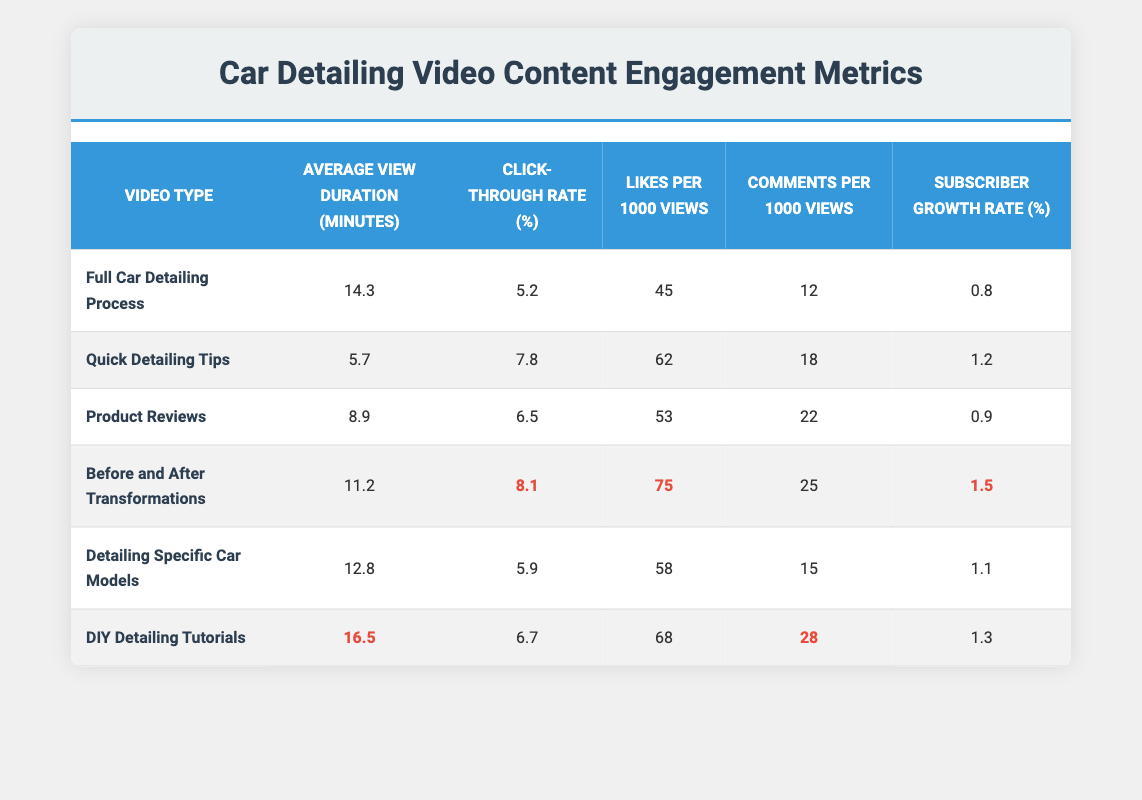What is the Average View Duration for "Full Car Detailing Process"? The Average View Duration for "Full Car Detailing Process" is listed in the table. It shows 14.3 minutes.
Answer: 14.3 minutes Which video type has the highest Click-Through Rate? The Click-Through Rate values are compared across all video types in the table. "Before and After Transformations" has the highest Click-Through Rate at 8.1%.
Answer: 8.1% How many Likes per 1000 Views does "DIY Detailing Tutorials" have? Referring directly to the table, "DIY Detailing Tutorials" shows 68 Likes per 1000 Views.
Answer: 68 Likes per 1000 Views What is the difference in Subscriber Growth Rate between "Before and After Transformations" and "Product Reviews"? From the table, "Before and After Transformations" has a Subscriber Growth Rate of 1.5% and "Product Reviews" has 0.9%. The difference is calculated as 1.5 - 0.9 = 0.6%.
Answer: 0.6% Is the Average View Duration of "Quick Detailing Tips" greater than that of "Detailing Specific Car Models"? The Average View Duration for "Quick Detailing Tips" is 5.7 minutes, and for "Detailing Specific Car Models," it is 12.8 minutes. Since 5.7 is less than 12.8, the statement is false.
Answer: No What is the Average View Duration across all video types? To find the Average View Duration, sum up the durations (14.3 + 5.7 + 8.9 + 11.2 + 12.8 + 16.5) which equals 69.4 minutes, then divide by 6 (the number of video types). So, 69.4 / 6 = 11.57 minutes (approximately).
Answer: 11.57 minutes Does "Before and After Transformations" have both the highest Likes per 1000 Views and Comments per 1000 Views? Looking at the table, "Before and After Transformations" has 75 Likes per 1000 Views and 25 Comments per 1000 Views. Comparing these to other video types shows that while it has the highest Likes, another video type may have a higher number of Comments, which in this case "DIY Detailing Tutorials" has 28. Therefore, the statement is false.
Answer: No Which video type has the lowest Subscriber Growth Rate? The table indicates that "Full Car Detailing Process" has the lowest Subscriber Growth Rate at 0.8% when compared to others.
Answer: 0.8% 